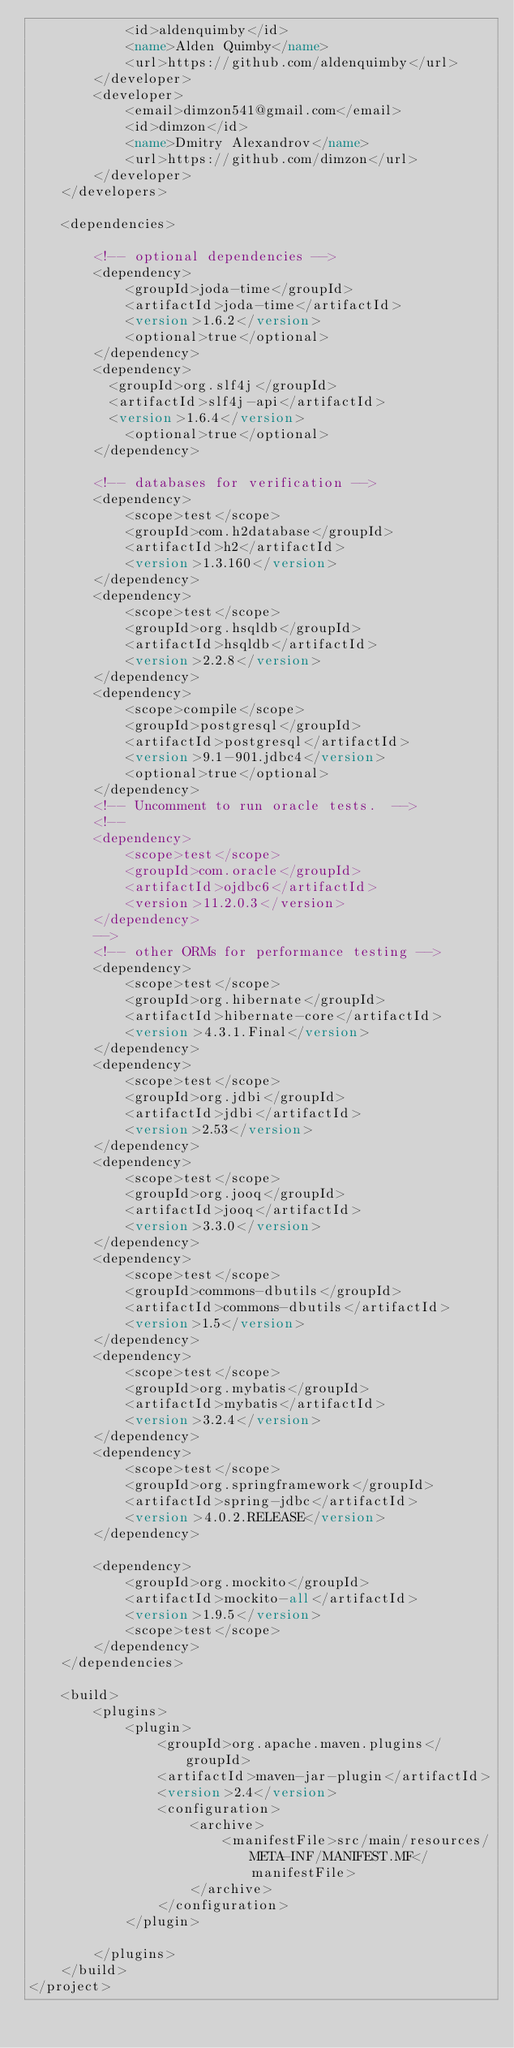Convert code to text. <code><loc_0><loc_0><loc_500><loc_500><_XML_>            <id>aldenquimby</id>
            <name>Alden Quimby</name>
            <url>https://github.com/aldenquimby</url>
        </developer>
        <developer>
            <email>dimzon541@gmail.com</email>
            <id>dimzon</id>
            <name>Dmitry Alexandrov</name>
            <url>https://github.com/dimzon</url>
        </developer>
    </developers>

    <dependencies>

        <!-- optional dependencies -->
        <dependency>
            <groupId>joda-time</groupId>
            <artifactId>joda-time</artifactId>
            <version>1.6.2</version>
            <optional>true</optional>
        </dependency>
        <dependency>
        	<groupId>org.slf4j</groupId>
        	<artifactId>slf4j-api</artifactId>
        	<version>1.6.4</version>
            <optional>true</optional>
        </dependency>

        <!-- databases for verification -->
        <dependency>
            <scope>test</scope>
            <groupId>com.h2database</groupId>
            <artifactId>h2</artifactId>
            <version>1.3.160</version>
        </dependency>
        <dependency>
            <scope>test</scope>
            <groupId>org.hsqldb</groupId>
            <artifactId>hsqldb</artifactId>
            <version>2.2.8</version>
        </dependency>
        <dependency>
            <scope>compile</scope>
            <groupId>postgresql</groupId>
            <artifactId>postgresql</artifactId>
            <version>9.1-901.jdbc4</version>
            <optional>true</optional>
        </dependency>
        <!-- Uncomment to run oracle tests.  -->
        <!--
        <dependency>
            <scope>test</scope>
            <groupId>com.oracle</groupId>
            <artifactId>ojdbc6</artifactId>
            <version>11.2.0.3</version>
        </dependency>
        -->
        <!-- other ORMs for performance testing -->
        <dependency>
            <scope>test</scope>
            <groupId>org.hibernate</groupId>
            <artifactId>hibernate-core</artifactId>
            <version>4.3.1.Final</version>
        </dependency>
        <dependency>
            <scope>test</scope>
            <groupId>org.jdbi</groupId>
            <artifactId>jdbi</artifactId>
            <version>2.53</version>
        </dependency>
        <dependency>
            <scope>test</scope>
            <groupId>org.jooq</groupId>
            <artifactId>jooq</artifactId>
            <version>3.3.0</version>
        </dependency>
        <dependency>
            <scope>test</scope>
            <groupId>commons-dbutils</groupId>
            <artifactId>commons-dbutils</artifactId>
            <version>1.5</version>
        </dependency>
        <dependency>
            <scope>test</scope>
            <groupId>org.mybatis</groupId>
            <artifactId>mybatis</artifactId>
            <version>3.2.4</version>
        </dependency>
        <dependency>
            <scope>test</scope>
            <groupId>org.springframework</groupId>
            <artifactId>spring-jdbc</artifactId>
            <version>4.0.2.RELEASE</version>
        </dependency>

        <dependency>
            <groupId>org.mockito</groupId>
            <artifactId>mockito-all</artifactId>
            <version>1.9.5</version>
            <scope>test</scope>
        </dependency>
    </dependencies>

    <build>
        <plugins>
            <plugin>
                <groupId>org.apache.maven.plugins</groupId>
                <artifactId>maven-jar-plugin</artifactId>
                <version>2.4</version>
                <configuration>
                    <archive>
                        <manifestFile>src/main/resources/META-INF/MANIFEST.MF</manifestFile>
                    </archive>
                </configuration>
            </plugin>

        </plugins>
    </build>
</project></code> 